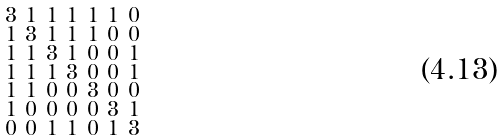<formula> <loc_0><loc_0><loc_500><loc_500>\begin{smallmatrix} 3 & 1 & 1 & 1 & 1 & 1 & 0 \\ 1 & 3 & 1 & 1 & 1 & 0 & 0 \\ 1 & 1 & 3 & 1 & 0 & 0 & 1 \\ 1 & 1 & 1 & 3 & 0 & 0 & 1 \\ 1 & 1 & 0 & 0 & 3 & 0 & 0 \\ 1 & 0 & 0 & 0 & 0 & 3 & 1 \\ 0 & 0 & 1 & 1 & 0 & 1 & 3 \end{smallmatrix}</formula> 